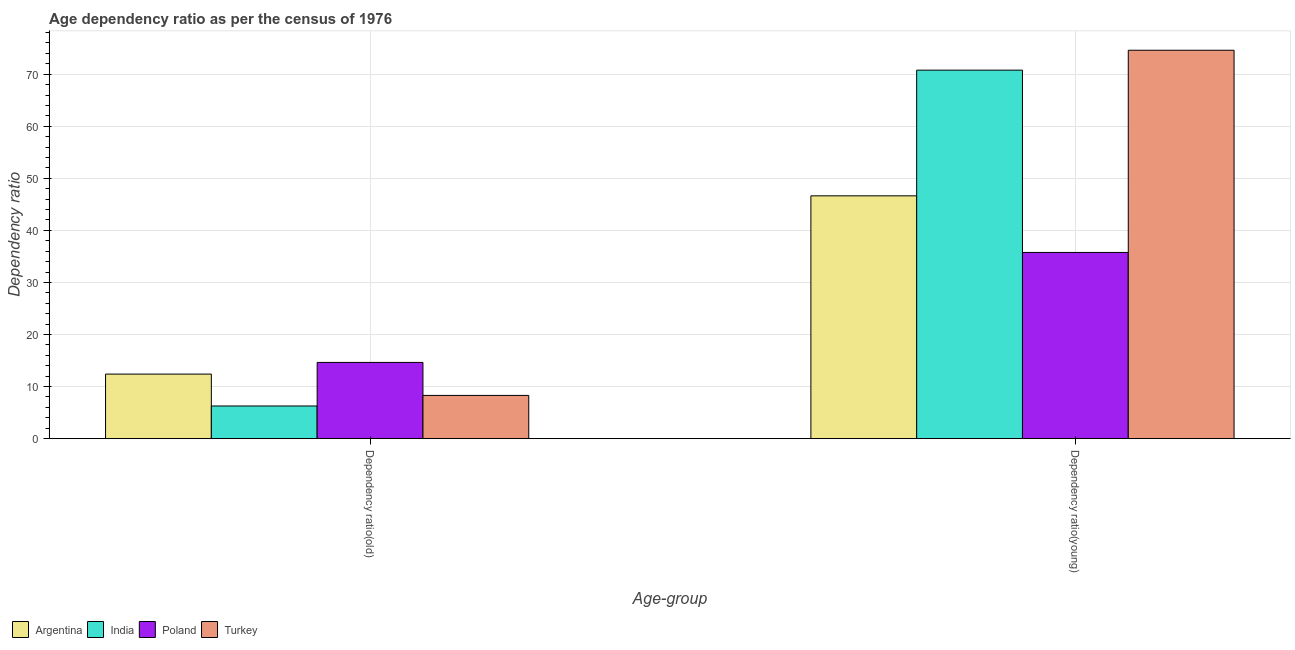How many different coloured bars are there?
Your answer should be very brief. 4. Are the number of bars on each tick of the X-axis equal?
Your answer should be very brief. Yes. How many bars are there on the 2nd tick from the right?
Provide a succinct answer. 4. What is the label of the 1st group of bars from the left?
Provide a succinct answer. Dependency ratio(old). What is the age dependency ratio(young) in Turkey?
Keep it short and to the point. 74.6. Across all countries, what is the maximum age dependency ratio(old)?
Provide a short and direct response. 14.64. Across all countries, what is the minimum age dependency ratio(old)?
Keep it short and to the point. 6.26. In which country was the age dependency ratio(young) maximum?
Your response must be concise. Turkey. What is the total age dependency ratio(young) in the graph?
Give a very brief answer. 227.76. What is the difference between the age dependency ratio(old) in Argentina and that in Turkey?
Your answer should be very brief. 4.1. What is the difference between the age dependency ratio(old) in Turkey and the age dependency ratio(young) in India?
Offer a terse response. -62.48. What is the average age dependency ratio(old) per country?
Your response must be concise. 10.4. What is the difference between the age dependency ratio(old) and age dependency ratio(young) in Poland?
Your response must be concise. -21.12. In how many countries, is the age dependency ratio(old) greater than 48 ?
Offer a terse response. 0. What is the ratio of the age dependency ratio(old) in Turkey to that in India?
Ensure brevity in your answer.  1.32. What does the 1st bar from the right in Dependency ratio(old) represents?
Ensure brevity in your answer.  Turkey. What is the difference between two consecutive major ticks on the Y-axis?
Keep it short and to the point. 10. Does the graph contain any zero values?
Ensure brevity in your answer.  No. Does the graph contain grids?
Your answer should be very brief. Yes. How are the legend labels stacked?
Provide a short and direct response. Horizontal. What is the title of the graph?
Make the answer very short. Age dependency ratio as per the census of 1976. Does "Belgium" appear as one of the legend labels in the graph?
Your answer should be very brief. No. What is the label or title of the X-axis?
Make the answer very short. Age-group. What is the label or title of the Y-axis?
Provide a short and direct response. Dependency ratio. What is the Dependency ratio of Argentina in Dependency ratio(old)?
Your answer should be compact. 12.39. What is the Dependency ratio in India in Dependency ratio(old)?
Offer a terse response. 6.26. What is the Dependency ratio of Poland in Dependency ratio(old)?
Provide a succinct answer. 14.64. What is the Dependency ratio in Turkey in Dependency ratio(old)?
Keep it short and to the point. 8.3. What is the Dependency ratio in Argentina in Dependency ratio(young)?
Make the answer very short. 46.63. What is the Dependency ratio of India in Dependency ratio(young)?
Offer a terse response. 70.77. What is the Dependency ratio in Poland in Dependency ratio(young)?
Ensure brevity in your answer.  35.76. What is the Dependency ratio in Turkey in Dependency ratio(young)?
Give a very brief answer. 74.6. Across all Age-group, what is the maximum Dependency ratio of Argentina?
Offer a very short reply. 46.63. Across all Age-group, what is the maximum Dependency ratio in India?
Give a very brief answer. 70.77. Across all Age-group, what is the maximum Dependency ratio in Poland?
Ensure brevity in your answer.  35.76. Across all Age-group, what is the maximum Dependency ratio of Turkey?
Your answer should be very brief. 74.6. Across all Age-group, what is the minimum Dependency ratio in Argentina?
Your answer should be very brief. 12.39. Across all Age-group, what is the minimum Dependency ratio of India?
Your answer should be very brief. 6.26. Across all Age-group, what is the minimum Dependency ratio of Poland?
Make the answer very short. 14.64. Across all Age-group, what is the minimum Dependency ratio in Turkey?
Give a very brief answer. 8.3. What is the total Dependency ratio in Argentina in the graph?
Your response must be concise. 59.03. What is the total Dependency ratio of India in the graph?
Your response must be concise. 77.04. What is the total Dependency ratio in Poland in the graph?
Make the answer very short. 50.4. What is the total Dependency ratio of Turkey in the graph?
Provide a succinct answer. 82.9. What is the difference between the Dependency ratio of Argentina in Dependency ratio(old) and that in Dependency ratio(young)?
Make the answer very short. -34.24. What is the difference between the Dependency ratio in India in Dependency ratio(old) and that in Dependency ratio(young)?
Offer a terse response. -64.51. What is the difference between the Dependency ratio in Poland in Dependency ratio(old) and that in Dependency ratio(young)?
Your answer should be compact. -21.12. What is the difference between the Dependency ratio of Turkey in Dependency ratio(old) and that in Dependency ratio(young)?
Provide a short and direct response. -66.3. What is the difference between the Dependency ratio of Argentina in Dependency ratio(old) and the Dependency ratio of India in Dependency ratio(young)?
Your answer should be compact. -58.38. What is the difference between the Dependency ratio of Argentina in Dependency ratio(old) and the Dependency ratio of Poland in Dependency ratio(young)?
Ensure brevity in your answer.  -23.37. What is the difference between the Dependency ratio of Argentina in Dependency ratio(old) and the Dependency ratio of Turkey in Dependency ratio(young)?
Give a very brief answer. -62.2. What is the difference between the Dependency ratio in India in Dependency ratio(old) and the Dependency ratio in Poland in Dependency ratio(young)?
Your response must be concise. -29.5. What is the difference between the Dependency ratio in India in Dependency ratio(old) and the Dependency ratio in Turkey in Dependency ratio(young)?
Provide a succinct answer. -68.33. What is the difference between the Dependency ratio of Poland in Dependency ratio(old) and the Dependency ratio of Turkey in Dependency ratio(young)?
Make the answer very short. -59.96. What is the average Dependency ratio in Argentina per Age-group?
Provide a succinct answer. 29.51. What is the average Dependency ratio in India per Age-group?
Provide a succinct answer. 38.52. What is the average Dependency ratio of Poland per Age-group?
Your answer should be compact. 25.2. What is the average Dependency ratio of Turkey per Age-group?
Give a very brief answer. 41.45. What is the difference between the Dependency ratio of Argentina and Dependency ratio of India in Dependency ratio(old)?
Offer a very short reply. 6.13. What is the difference between the Dependency ratio in Argentina and Dependency ratio in Poland in Dependency ratio(old)?
Your answer should be compact. -2.24. What is the difference between the Dependency ratio of Argentina and Dependency ratio of Turkey in Dependency ratio(old)?
Make the answer very short. 4.1. What is the difference between the Dependency ratio of India and Dependency ratio of Poland in Dependency ratio(old)?
Your response must be concise. -8.37. What is the difference between the Dependency ratio of India and Dependency ratio of Turkey in Dependency ratio(old)?
Provide a short and direct response. -2.03. What is the difference between the Dependency ratio in Poland and Dependency ratio in Turkey in Dependency ratio(old)?
Your answer should be compact. 6.34. What is the difference between the Dependency ratio in Argentina and Dependency ratio in India in Dependency ratio(young)?
Offer a terse response. -24.14. What is the difference between the Dependency ratio of Argentina and Dependency ratio of Poland in Dependency ratio(young)?
Offer a very short reply. 10.87. What is the difference between the Dependency ratio of Argentina and Dependency ratio of Turkey in Dependency ratio(young)?
Provide a short and direct response. -27.96. What is the difference between the Dependency ratio of India and Dependency ratio of Poland in Dependency ratio(young)?
Give a very brief answer. 35.01. What is the difference between the Dependency ratio of India and Dependency ratio of Turkey in Dependency ratio(young)?
Keep it short and to the point. -3.82. What is the difference between the Dependency ratio in Poland and Dependency ratio in Turkey in Dependency ratio(young)?
Your answer should be very brief. -38.84. What is the ratio of the Dependency ratio in Argentina in Dependency ratio(old) to that in Dependency ratio(young)?
Offer a terse response. 0.27. What is the ratio of the Dependency ratio in India in Dependency ratio(old) to that in Dependency ratio(young)?
Provide a short and direct response. 0.09. What is the ratio of the Dependency ratio in Poland in Dependency ratio(old) to that in Dependency ratio(young)?
Offer a terse response. 0.41. What is the ratio of the Dependency ratio in Turkey in Dependency ratio(old) to that in Dependency ratio(young)?
Ensure brevity in your answer.  0.11. What is the difference between the highest and the second highest Dependency ratio of Argentina?
Ensure brevity in your answer.  34.24. What is the difference between the highest and the second highest Dependency ratio of India?
Keep it short and to the point. 64.51. What is the difference between the highest and the second highest Dependency ratio of Poland?
Your response must be concise. 21.12. What is the difference between the highest and the second highest Dependency ratio of Turkey?
Provide a short and direct response. 66.3. What is the difference between the highest and the lowest Dependency ratio in Argentina?
Provide a short and direct response. 34.24. What is the difference between the highest and the lowest Dependency ratio in India?
Keep it short and to the point. 64.51. What is the difference between the highest and the lowest Dependency ratio in Poland?
Your response must be concise. 21.12. What is the difference between the highest and the lowest Dependency ratio of Turkey?
Provide a short and direct response. 66.3. 